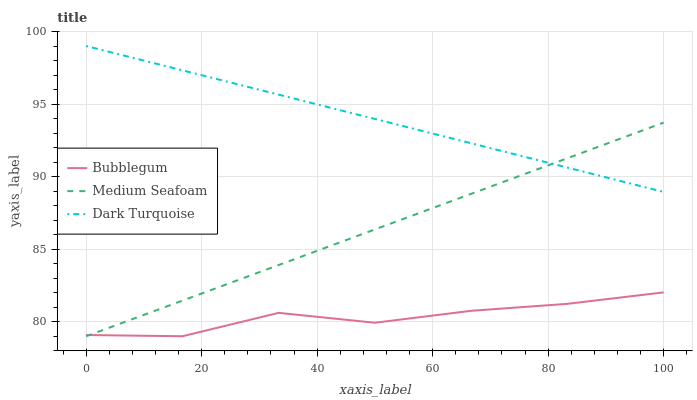Does Bubblegum have the minimum area under the curve?
Answer yes or no. Yes. Does Dark Turquoise have the maximum area under the curve?
Answer yes or no. Yes. Does Medium Seafoam have the minimum area under the curve?
Answer yes or no. No. Does Medium Seafoam have the maximum area under the curve?
Answer yes or no. No. Is Dark Turquoise the smoothest?
Answer yes or no. Yes. Is Bubblegum the roughest?
Answer yes or no. Yes. Is Medium Seafoam the smoothest?
Answer yes or no. No. Is Medium Seafoam the roughest?
Answer yes or no. No. Does Medium Seafoam have the lowest value?
Answer yes or no. Yes. Does Dark Turquoise have the highest value?
Answer yes or no. Yes. Does Medium Seafoam have the highest value?
Answer yes or no. No. Is Bubblegum less than Dark Turquoise?
Answer yes or no. Yes. Is Dark Turquoise greater than Bubblegum?
Answer yes or no. Yes. Does Dark Turquoise intersect Medium Seafoam?
Answer yes or no. Yes. Is Dark Turquoise less than Medium Seafoam?
Answer yes or no. No. Is Dark Turquoise greater than Medium Seafoam?
Answer yes or no. No. Does Bubblegum intersect Dark Turquoise?
Answer yes or no. No. 